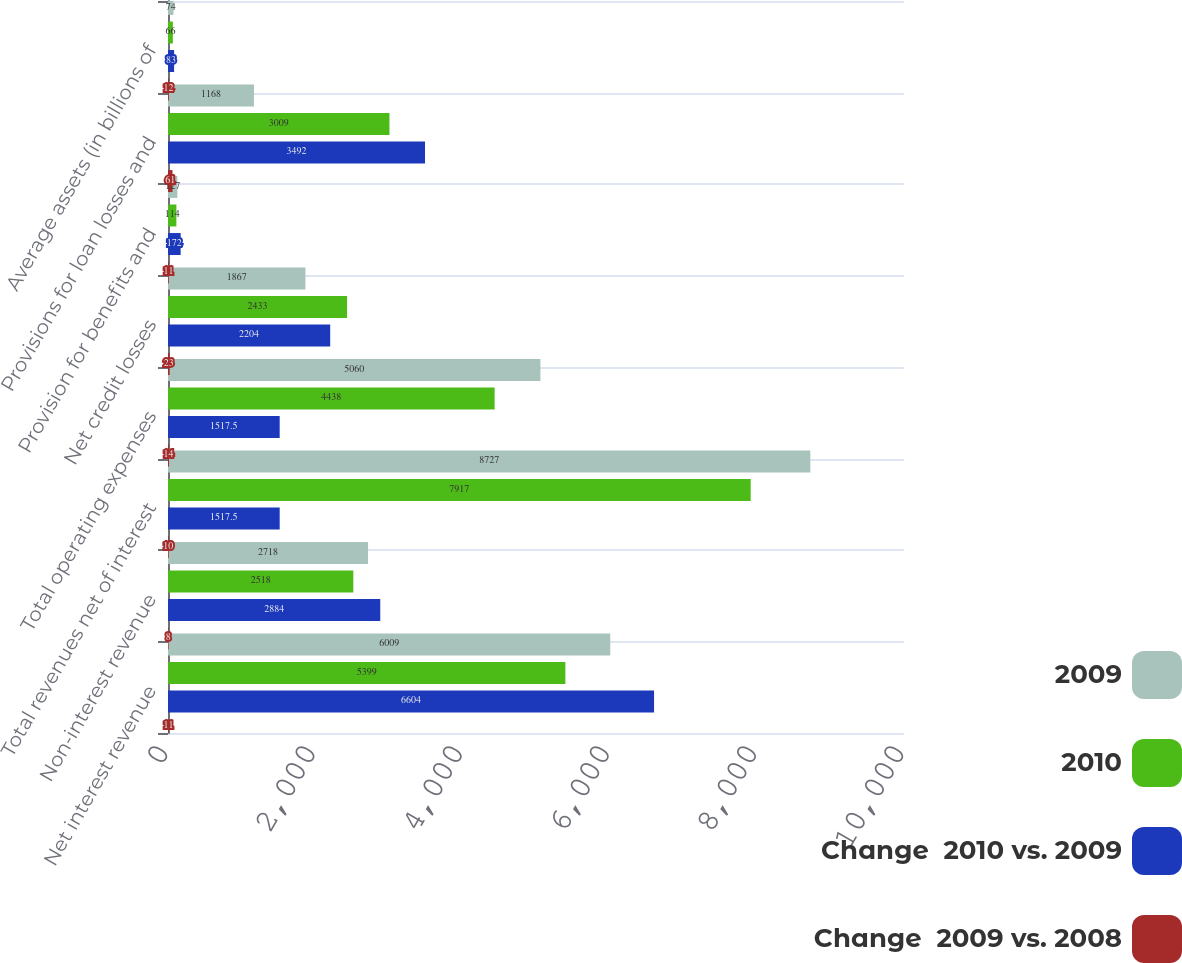Convert chart. <chart><loc_0><loc_0><loc_500><loc_500><stacked_bar_chart><ecel><fcel>Net interest revenue<fcel>Non-interest revenue<fcel>Total revenues net of interest<fcel>Total operating expenses<fcel>Net credit losses<fcel>Provision for benefits and<fcel>Provisions for loan losses and<fcel>Average assets (in billions of<nl><fcel>2009<fcel>6009<fcel>2718<fcel>8727<fcel>5060<fcel>1867<fcel>127<fcel>1168<fcel>74<nl><fcel>2010<fcel>5399<fcel>2518<fcel>7917<fcel>4438<fcel>2433<fcel>114<fcel>3009<fcel>66<nl><fcel>Change  2010 vs. 2009<fcel>6604<fcel>2884<fcel>1517.5<fcel>1517.5<fcel>2204<fcel>172<fcel>3492<fcel>83<nl><fcel>Change  2009 vs. 2008<fcel>11<fcel>8<fcel>10<fcel>14<fcel>23<fcel>11<fcel>61<fcel>12<nl></chart> 